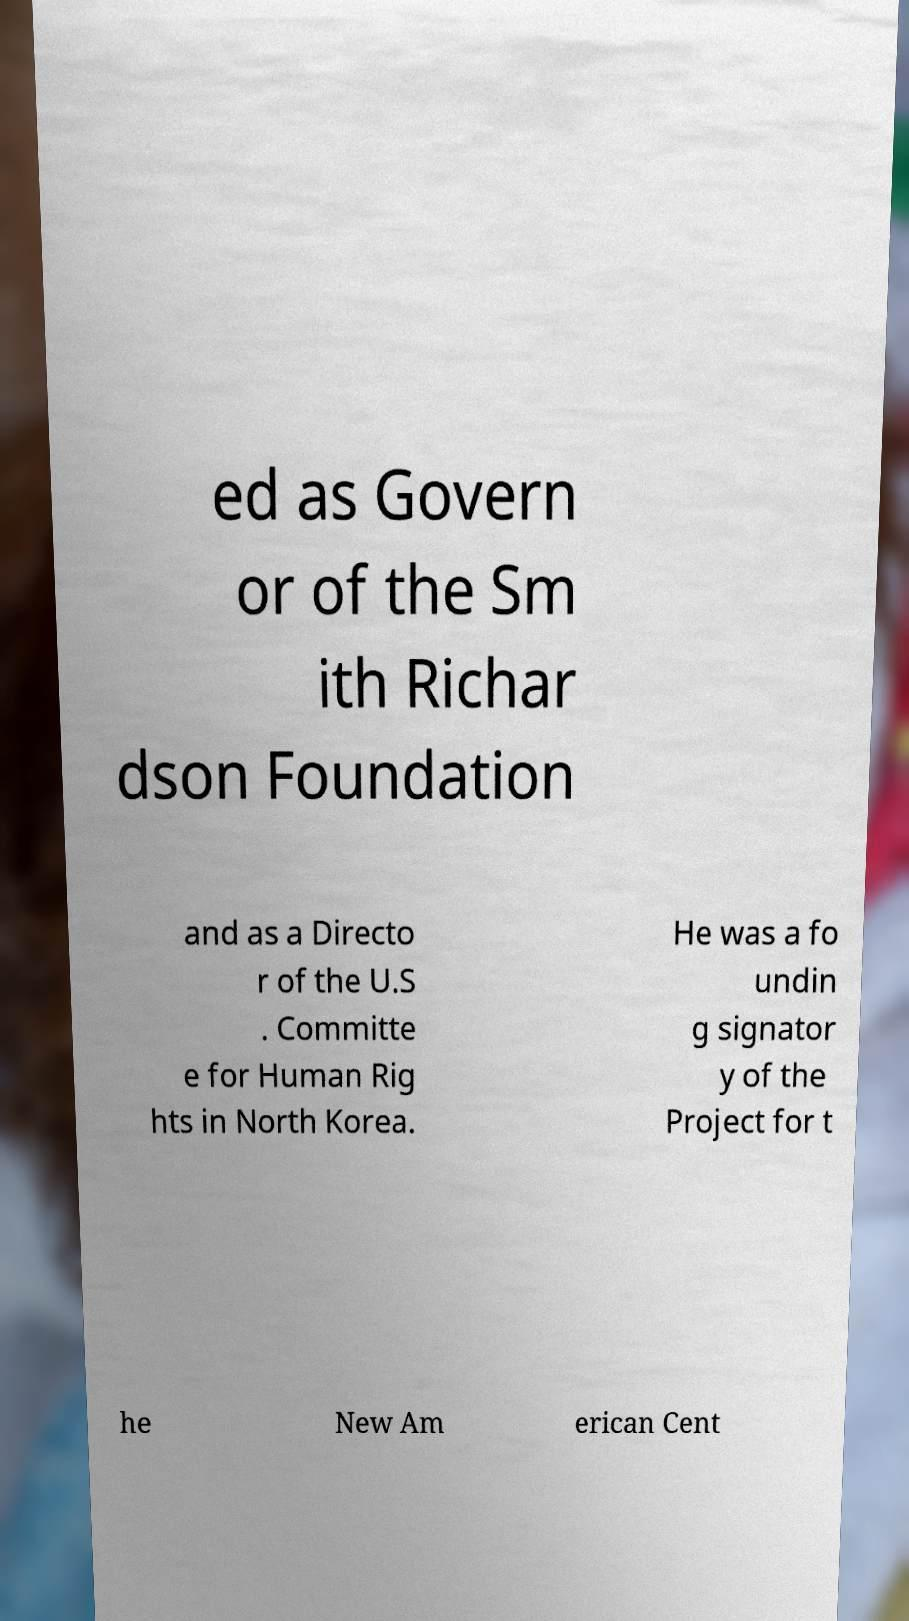Can you read and provide the text displayed in the image?This photo seems to have some interesting text. Can you extract and type it out for me? ed as Govern or of the Sm ith Richar dson Foundation and as a Directo r of the U.S . Committe e for Human Rig hts in North Korea. He was a fo undin g signator y of the Project for t he New Am erican Cent 